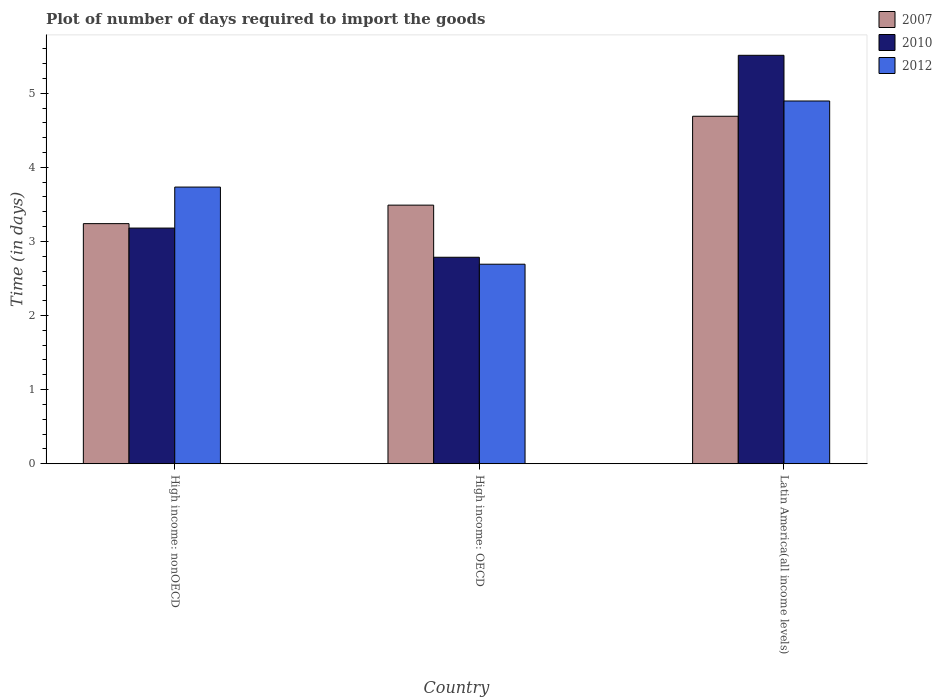How many different coloured bars are there?
Make the answer very short. 3. How many groups of bars are there?
Keep it short and to the point. 3. What is the label of the 2nd group of bars from the left?
Your answer should be very brief. High income: OECD. In how many cases, is the number of bars for a given country not equal to the number of legend labels?
Give a very brief answer. 0. What is the time required to import goods in 2007 in High income: nonOECD?
Your answer should be very brief. 3.24. Across all countries, what is the maximum time required to import goods in 2007?
Keep it short and to the point. 4.69. Across all countries, what is the minimum time required to import goods in 2007?
Make the answer very short. 3.24. In which country was the time required to import goods in 2012 maximum?
Ensure brevity in your answer.  Latin America(all income levels). In which country was the time required to import goods in 2007 minimum?
Provide a succinct answer. High income: nonOECD. What is the total time required to import goods in 2012 in the graph?
Your response must be concise. 11.32. What is the difference between the time required to import goods in 2012 in High income: OECD and that in High income: nonOECD?
Provide a succinct answer. -1.04. What is the difference between the time required to import goods in 2010 in High income: OECD and the time required to import goods in 2007 in High income: nonOECD?
Offer a very short reply. -0.45. What is the average time required to import goods in 2007 per country?
Offer a very short reply. 3.81. What is the difference between the time required to import goods of/in 2012 and time required to import goods of/in 2007 in High income: OECD?
Offer a very short reply. -0.8. What is the ratio of the time required to import goods in 2010 in High income: OECD to that in High income: nonOECD?
Give a very brief answer. 0.88. Is the difference between the time required to import goods in 2012 in High income: OECD and High income: nonOECD greater than the difference between the time required to import goods in 2007 in High income: OECD and High income: nonOECD?
Provide a short and direct response. No. What is the difference between the highest and the second highest time required to import goods in 2010?
Offer a very short reply. -0.39. What is the difference between the highest and the lowest time required to import goods in 2007?
Your answer should be very brief. 1.45. In how many countries, is the time required to import goods in 2012 greater than the average time required to import goods in 2012 taken over all countries?
Make the answer very short. 1. How many bars are there?
Make the answer very short. 9. Are all the bars in the graph horizontal?
Make the answer very short. No. What is the difference between two consecutive major ticks on the Y-axis?
Provide a succinct answer. 1. Does the graph contain any zero values?
Ensure brevity in your answer.  No. Does the graph contain grids?
Keep it short and to the point. No. How many legend labels are there?
Your answer should be very brief. 3. What is the title of the graph?
Keep it short and to the point. Plot of number of days required to import the goods. What is the label or title of the Y-axis?
Offer a terse response. Time (in days). What is the Time (in days) of 2007 in High income: nonOECD?
Your response must be concise. 3.24. What is the Time (in days) in 2010 in High income: nonOECD?
Offer a very short reply. 3.18. What is the Time (in days) of 2012 in High income: nonOECD?
Your response must be concise. 3.73. What is the Time (in days) of 2007 in High income: OECD?
Keep it short and to the point. 3.49. What is the Time (in days) of 2010 in High income: OECD?
Ensure brevity in your answer.  2.79. What is the Time (in days) of 2012 in High income: OECD?
Your response must be concise. 2.69. What is the Time (in days) in 2007 in Latin America(all income levels)?
Your answer should be compact. 4.69. What is the Time (in days) of 2010 in Latin America(all income levels)?
Your answer should be compact. 5.51. What is the Time (in days) in 2012 in Latin America(all income levels)?
Your response must be concise. 4.89. Across all countries, what is the maximum Time (in days) of 2007?
Your answer should be compact. 4.69. Across all countries, what is the maximum Time (in days) in 2010?
Keep it short and to the point. 5.51. Across all countries, what is the maximum Time (in days) of 2012?
Give a very brief answer. 4.89. Across all countries, what is the minimum Time (in days) of 2007?
Provide a short and direct response. 3.24. Across all countries, what is the minimum Time (in days) in 2010?
Offer a terse response. 2.79. Across all countries, what is the minimum Time (in days) of 2012?
Provide a succinct answer. 2.69. What is the total Time (in days) of 2007 in the graph?
Your answer should be compact. 11.42. What is the total Time (in days) in 2010 in the graph?
Provide a succinct answer. 11.48. What is the total Time (in days) in 2012 in the graph?
Offer a terse response. 11.32. What is the difference between the Time (in days) of 2007 in High income: nonOECD and that in High income: OECD?
Provide a succinct answer. -0.25. What is the difference between the Time (in days) of 2010 in High income: nonOECD and that in High income: OECD?
Offer a terse response. 0.39. What is the difference between the Time (in days) of 2012 in High income: nonOECD and that in High income: OECD?
Your answer should be very brief. 1.04. What is the difference between the Time (in days) in 2007 in High income: nonOECD and that in Latin America(all income levels)?
Make the answer very short. -1.45. What is the difference between the Time (in days) of 2010 in High income: nonOECD and that in Latin America(all income levels)?
Your answer should be compact. -2.33. What is the difference between the Time (in days) in 2012 in High income: nonOECD and that in Latin America(all income levels)?
Give a very brief answer. -1.16. What is the difference between the Time (in days) in 2007 in High income: OECD and that in Latin America(all income levels)?
Offer a very short reply. -1.2. What is the difference between the Time (in days) of 2010 in High income: OECD and that in Latin America(all income levels)?
Keep it short and to the point. -2.73. What is the difference between the Time (in days) in 2012 in High income: OECD and that in Latin America(all income levels)?
Keep it short and to the point. -2.2. What is the difference between the Time (in days) in 2007 in High income: nonOECD and the Time (in days) in 2010 in High income: OECD?
Your response must be concise. 0.45. What is the difference between the Time (in days) of 2007 in High income: nonOECD and the Time (in days) of 2012 in High income: OECD?
Ensure brevity in your answer.  0.55. What is the difference between the Time (in days) in 2010 in High income: nonOECD and the Time (in days) in 2012 in High income: OECD?
Provide a succinct answer. 0.49. What is the difference between the Time (in days) of 2007 in High income: nonOECD and the Time (in days) of 2010 in Latin America(all income levels)?
Give a very brief answer. -2.27. What is the difference between the Time (in days) in 2007 in High income: nonOECD and the Time (in days) in 2012 in Latin America(all income levels)?
Your answer should be very brief. -1.65. What is the difference between the Time (in days) of 2010 in High income: nonOECD and the Time (in days) of 2012 in Latin America(all income levels)?
Provide a succinct answer. -1.71. What is the difference between the Time (in days) in 2007 in High income: OECD and the Time (in days) in 2010 in Latin America(all income levels)?
Your response must be concise. -2.02. What is the difference between the Time (in days) of 2007 in High income: OECD and the Time (in days) of 2012 in Latin America(all income levels)?
Your answer should be compact. -1.41. What is the difference between the Time (in days) of 2010 in High income: OECD and the Time (in days) of 2012 in Latin America(all income levels)?
Give a very brief answer. -2.11. What is the average Time (in days) in 2007 per country?
Offer a terse response. 3.81. What is the average Time (in days) of 2010 per country?
Offer a very short reply. 3.83. What is the average Time (in days) in 2012 per country?
Provide a short and direct response. 3.77. What is the difference between the Time (in days) in 2007 and Time (in days) in 2010 in High income: nonOECD?
Your response must be concise. 0.06. What is the difference between the Time (in days) of 2007 and Time (in days) of 2012 in High income: nonOECD?
Your answer should be very brief. -0.49. What is the difference between the Time (in days) of 2010 and Time (in days) of 2012 in High income: nonOECD?
Your answer should be compact. -0.55. What is the difference between the Time (in days) of 2007 and Time (in days) of 2010 in High income: OECD?
Offer a very short reply. 0.7. What is the difference between the Time (in days) in 2007 and Time (in days) in 2012 in High income: OECD?
Provide a succinct answer. 0.8. What is the difference between the Time (in days) of 2010 and Time (in days) of 2012 in High income: OECD?
Offer a very short reply. 0.09. What is the difference between the Time (in days) of 2007 and Time (in days) of 2010 in Latin America(all income levels)?
Offer a very short reply. -0.82. What is the difference between the Time (in days) in 2007 and Time (in days) in 2012 in Latin America(all income levels)?
Your answer should be very brief. -0.21. What is the difference between the Time (in days) of 2010 and Time (in days) of 2012 in Latin America(all income levels)?
Provide a short and direct response. 0.62. What is the ratio of the Time (in days) of 2007 in High income: nonOECD to that in High income: OECD?
Ensure brevity in your answer.  0.93. What is the ratio of the Time (in days) of 2010 in High income: nonOECD to that in High income: OECD?
Keep it short and to the point. 1.14. What is the ratio of the Time (in days) of 2012 in High income: nonOECD to that in High income: OECD?
Offer a very short reply. 1.39. What is the ratio of the Time (in days) of 2007 in High income: nonOECD to that in Latin America(all income levels)?
Give a very brief answer. 0.69. What is the ratio of the Time (in days) of 2010 in High income: nonOECD to that in Latin America(all income levels)?
Provide a short and direct response. 0.58. What is the ratio of the Time (in days) of 2012 in High income: nonOECD to that in Latin America(all income levels)?
Keep it short and to the point. 0.76. What is the ratio of the Time (in days) in 2007 in High income: OECD to that in Latin America(all income levels)?
Provide a short and direct response. 0.74. What is the ratio of the Time (in days) of 2010 in High income: OECD to that in Latin America(all income levels)?
Keep it short and to the point. 0.51. What is the ratio of the Time (in days) of 2012 in High income: OECD to that in Latin America(all income levels)?
Your response must be concise. 0.55. What is the difference between the highest and the second highest Time (in days) in 2007?
Provide a short and direct response. 1.2. What is the difference between the highest and the second highest Time (in days) in 2010?
Your answer should be compact. 2.33. What is the difference between the highest and the second highest Time (in days) of 2012?
Ensure brevity in your answer.  1.16. What is the difference between the highest and the lowest Time (in days) in 2007?
Keep it short and to the point. 1.45. What is the difference between the highest and the lowest Time (in days) in 2010?
Give a very brief answer. 2.73. What is the difference between the highest and the lowest Time (in days) of 2012?
Offer a very short reply. 2.2. 